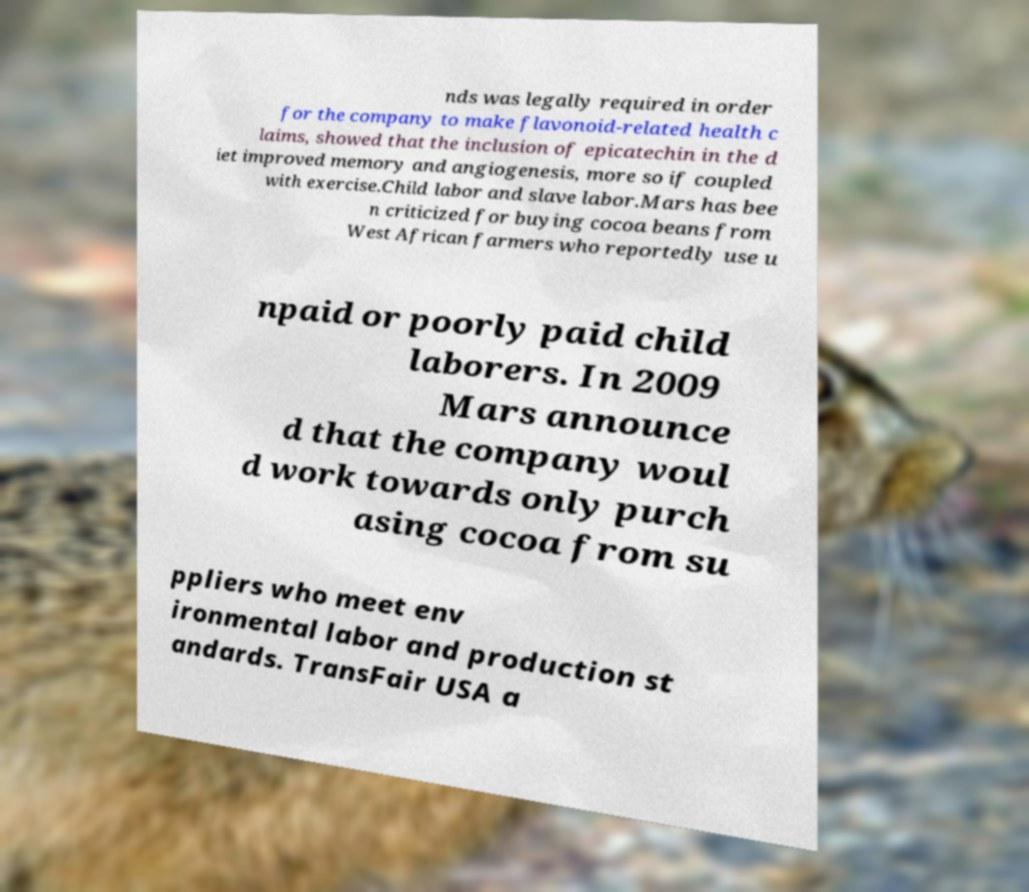Please identify and transcribe the text found in this image. nds was legally required in order for the company to make flavonoid-related health c laims, showed that the inclusion of epicatechin in the d iet improved memory and angiogenesis, more so if coupled with exercise.Child labor and slave labor.Mars has bee n criticized for buying cocoa beans from West African farmers who reportedly use u npaid or poorly paid child laborers. In 2009 Mars announce d that the company woul d work towards only purch asing cocoa from su ppliers who meet env ironmental labor and production st andards. TransFair USA a 